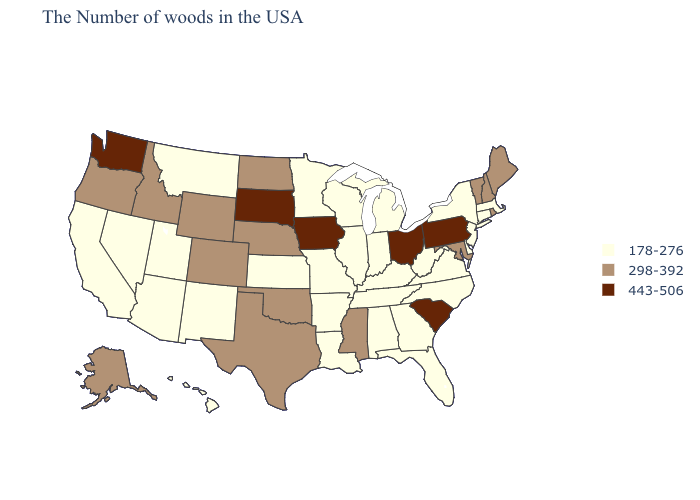Does Iowa have the highest value in the USA?
Keep it brief. Yes. Name the states that have a value in the range 298-392?
Short answer required. Maine, Rhode Island, New Hampshire, Vermont, Maryland, Mississippi, Nebraska, Oklahoma, Texas, North Dakota, Wyoming, Colorado, Idaho, Oregon, Alaska. What is the value of Hawaii?
Quick response, please. 178-276. Does Michigan have the lowest value in the USA?
Concise answer only. Yes. Name the states that have a value in the range 298-392?
Keep it brief. Maine, Rhode Island, New Hampshire, Vermont, Maryland, Mississippi, Nebraska, Oklahoma, Texas, North Dakota, Wyoming, Colorado, Idaho, Oregon, Alaska. What is the value of West Virginia?
Answer briefly. 178-276. Among the states that border Oklahoma , which have the highest value?
Write a very short answer. Texas, Colorado. What is the value of Kentucky?
Short answer required. 178-276. Name the states that have a value in the range 298-392?
Answer briefly. Maine, Rhode Island, New Hampshire, Vermont, Maryland, Mississippi, Nebraska, Oklahoma, Texas, North Dakota, Wyoming, Colorado, Idaho, Oregon, Alaska. Does West Virginia have a higher value than Georgia?
Concise answer only. No. What is the lowest value in the South?
Short answer required. 178-276. Among the states that border Maine , which have the lowest value?
Give a very brief answer. New Hampshire. Name the states that have a value in the range 178-276?
Keep it brief. Massachusetts, Connecticut, New York, New Jersey, Delaware, Virginia, North Carolina, West Virginia, Florida, Georgia, Michigan, Kentucky, Indiana, Alabama, Tennessee, Wisconsin, Illinois, Louisiana, Missouri, Arkansas, Minnesota, Kansas, New Mexico, Utah, Montana, Arizona, Nevada, California, Hawaii. Among the states that border Nevada , does California have the highest value?
Concise answer only. No. What is the highest value in the USA?
Give a very brief answer. 443-506. 